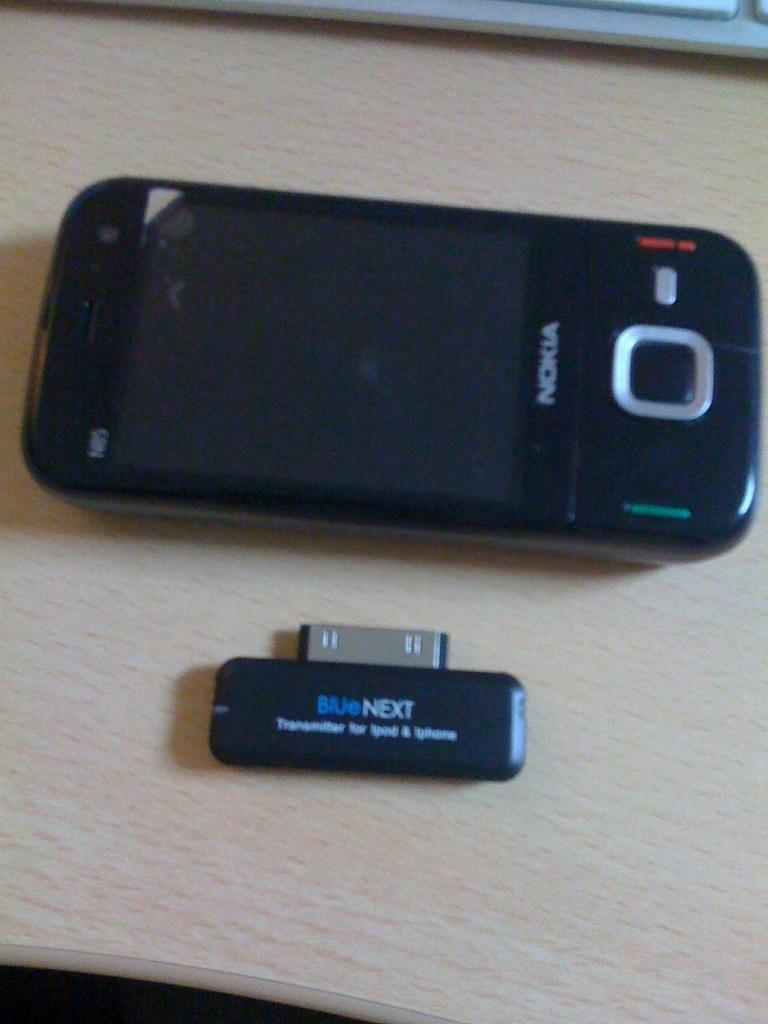Provide a one-sentence caption for the provided image. A black Nokia product and an attachment sit on a wood table. 